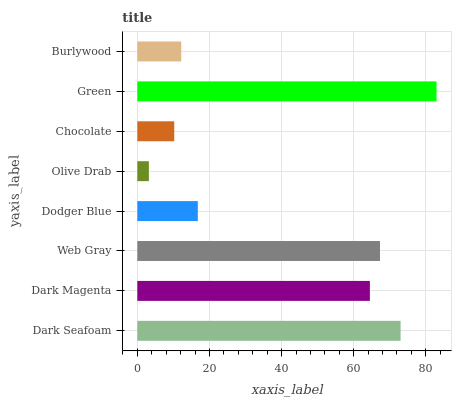Is Olive Drab the minimum?
Answer yes or no. Yes. Is Green the maximum?
Answer yes or no. Yes. Is Dark Magenta the minimum?
Answer yes or no. No. Is Dark Magenta the maximum?
Answer yes or no. No. Is Dark Seafoam greater than Dark Magenta?
Answer yes or no. Yes. Is Dark Magenta less than Dark Seafoam?
Answer yes or no. Yes. Is Dark Magenta greater than Dark Seafoam?
Answer yes or no. No. Is Dark Seafoam less than Dark Magenta?
Answer yes or no. No. Is Dark Magenta the high median?
Answer yes or no. Yes. Is Dodger Blue the low median?
Answer yes or no. Yes. Is Web Gray the high median?
Answer yes or no. No. Is Web Gray the low median?
Answer yes or no. No. 